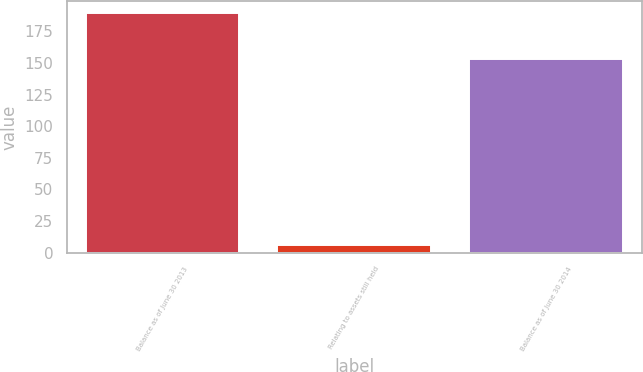Convert chart to OTSL. <chart><loc_0><loc_0><loc_500><loc_500><bar_chart><fcel>Balance as of June 30 2013<fcel>Relating to assets still held<fcel>Balance as of June 30 2014<nl><fcel>189.4<fcel>6.3<fcel>152.7<nl></chart> 